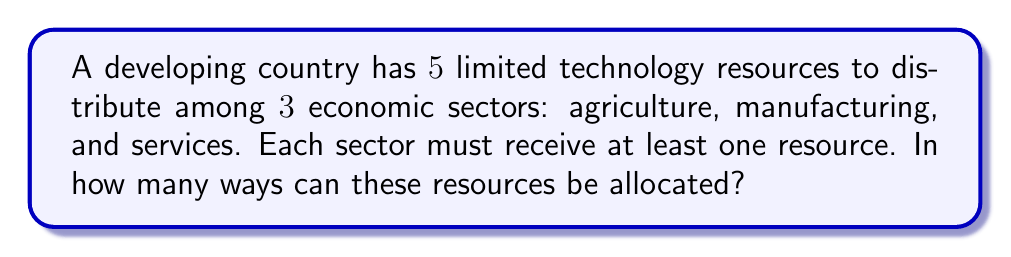What is the answer to this math problem? Let's approach this step-by-step:

1) This is a problem of distributing distinct objects (resources) into distinct boxes (sectors) with restrictions.

2) We can use the stars and bars method, but with a modification due to the restriction that each sector must receive at least one resource.

3) To ensure each sector gets at least one resource, we can first allocate one resource to each sector. This leaves us with $5 - 3 = 2$ resources to distribute freely.

4) Now, we have 2 resources to distribute among 3 sectors, with no restrictions. This is a standard stars and bars problem.

5) The formula for stars and bars is:

   $$\binom{n+k-1}{k-1}$$

   where $n$ is the number of objects (remaining resources) and $k$ is the number of boxes (sectors).

6) In this case, $n = 2$ and $k = 3$. So we calculate:

   $$\binom{2+3-1}{3-1} = \binom{4}{2}$$

7) We can calculate this combination:

   $$\binom{4}{2} = \frac{4!}{2!(4-2)!} = \frac{4 \cdot 3}{2 \cdot 1} = 6$$

Therefore, there are 6 ways to allocate the resources.
Answer: $6$ 